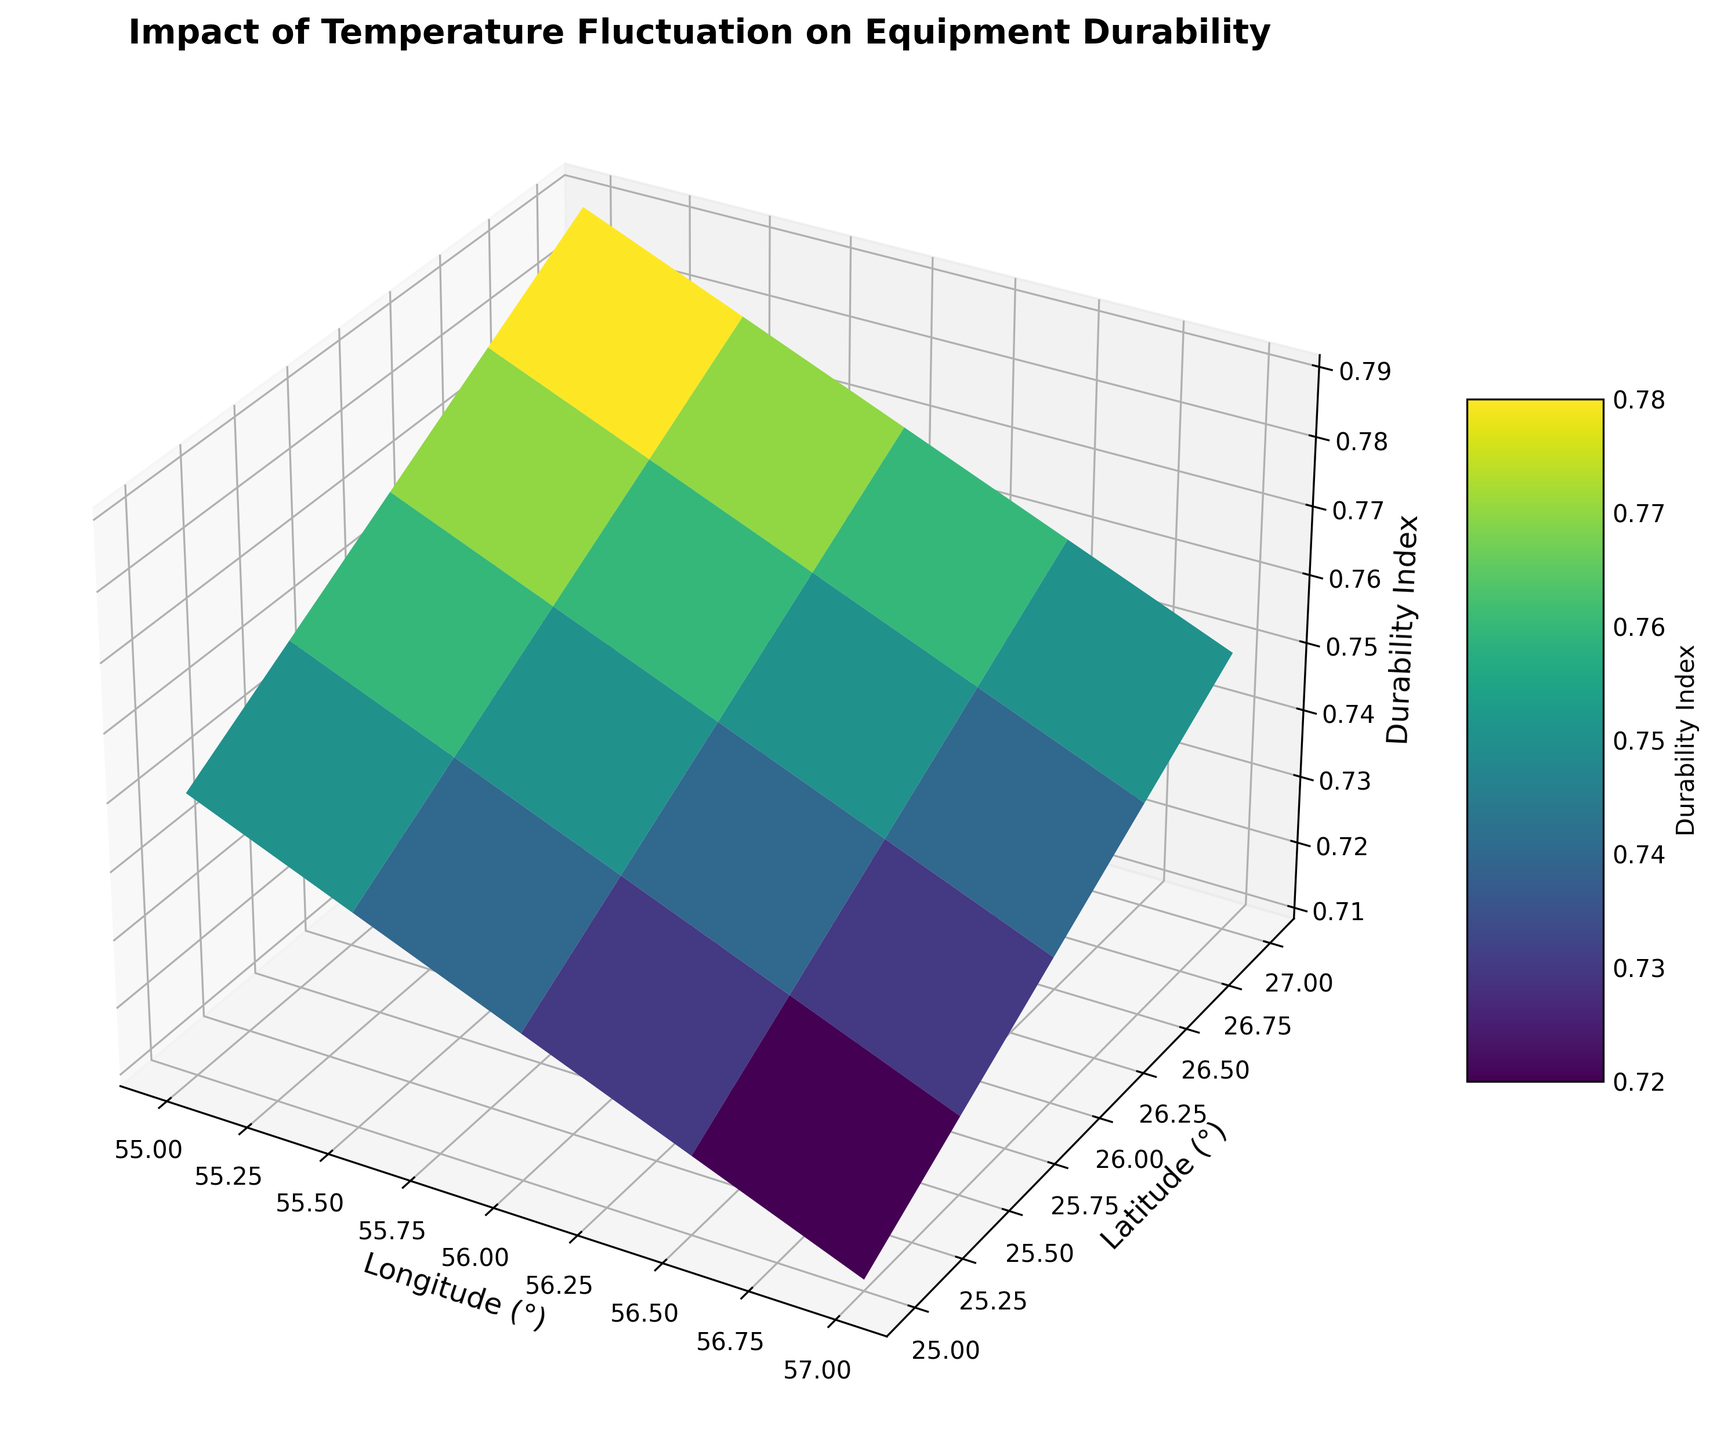What is the durability index at (latitude 25.5, longitude 56.0)? To find the durability index at (latitude 25.5, longitude 56.0), locate the grid point where latitude is 25.5 and longitude is 56.0, then read off the corresponding durability index value.
Answer: 0.74 Which latitude shows the highest durability index? To identify the highest durability index, examine the color variations and surface heights across different latitudes. The greenish or highest peak on the Z-axis often indicates the highest durability index.
Answer: 27.0 How does the durability index change as you move from longitude 55.0 to 57.0 at latitude 26.0? Track the surface's progression along the longitude (X-axis) from 55.0 to 57.0 at latitude 26.0. Observe how the height (Z-axis) shifts, higher values indicate a higher durability index.
Answer: Decreases At which longitude and latitude is the lowest durability index observed? To determine the lowest durability index, find the flattest and darkest color areas on the surface. These typically represent the points with minimum values on the Z-axis.
Answer: (25.0, 57.0) Is the durability index at (latitude 26.5, longitude 56.5) higher or lower than at (latitude 25.0, longitude 56.5)? Compare the surface heights at these two specific points. Higher points correspond to a higher durability index.
Answer: Lower Between latitudes 25.0 and 27.0, which one experiences the most significant temperature fluctuations based on color intensity and height changes? Look at the gradient variations along the Z-axis and color intensity for each latitude band. Large changes in height and color reveal significant temperature fluctuations.
Answer: 25.0 What is the general trend of the equipment durability index as you move from lower to higher latitudes? Observe how the surface height and color shifting along the Y-axis (latitude). Identify if it generally ascends, descends, or remains flat.
Answer: Increases Comparing the durability index at longitude 55.5 across latitudes from 25.0 to 27.0, which latitude has the lowest durability index? Determine the durability index along longitude 55.5 by inspecting the height and darkness at each latitude. Find the lowest value among them.
Answer: 25.0 Considering the entire data range, where do you see the highest variability in durability index values? Assess the figure for regions with steep peaks and valleys or pronounced color changes. High variability is noticed where the Z-axis values fluctuate intensely.
Answer: Around latitude 25.0 and longitude 57.0 How does the durability index at (latitude 26.0, longitude 55.0) compare to the average durability index across all data points? Identify the durability index at the specified coordinates and calculate the average of all visible data points on the Z-axis. Compare the two values to note whether it's higher, lower, or equal.
Answer: Higher 